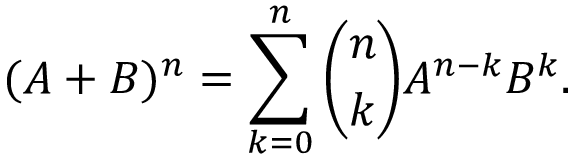<formula> <loc_0><loc_0><loc_500><loc_500>( A + B ) ^ { n } = \sum _ { k = 0 } ^ { n } \binom { n } { k } A ^ { n - k } B ^ { k } .</formula> 